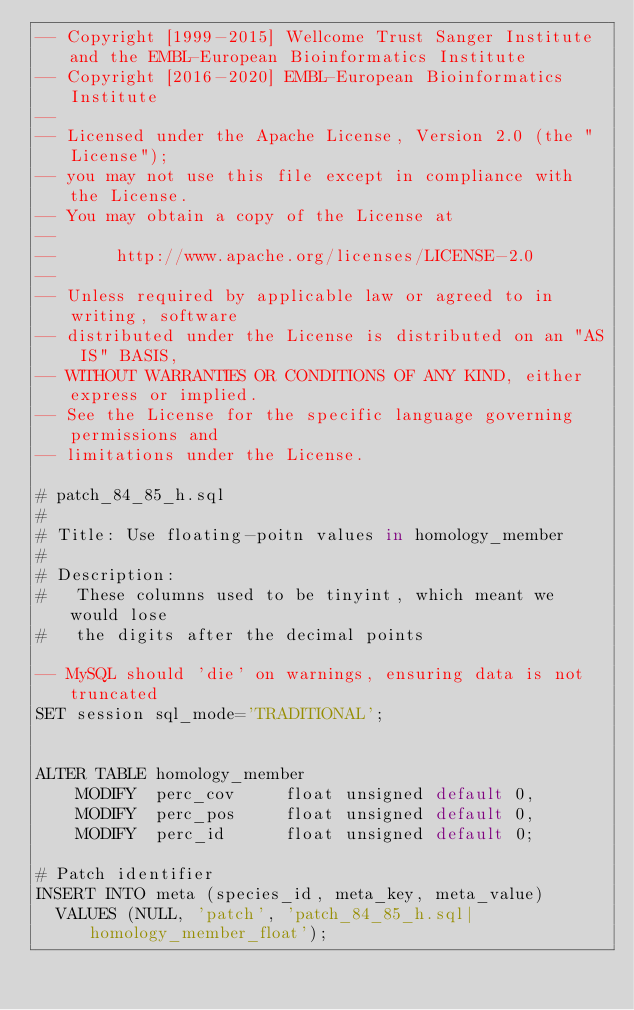Convert code to text. <code><loc_0><loc_0><loc_500><loc_500><_SQL_>-- Copyright [1999-2015] Wellcome Trust Sanger Institute and the EMBL-European Bioinformatics Institute
-- Copyright [2016-2020] EMBL-European Bioinformatics Institute
-- 
-- Licensed under the Apache License, Version 2.0 (the "License");
-- you may not use this file except in compliance with the License.
-- You may obtain a copy of the License at
-- 
--      http://www.apache.org/licenses/LICENSE-2.0
-- 
-- Unless required by applicable law or agreed to in writing, software
-- distributed under the License is distributed on an "AS IS" BASIS,
-- WITHOUT WARRANTIES OR CONDITIONS OF ANY KIND, either express or implied.
-- See the License for the specific language governing permissions and
-- limitations under the License.

# patch_84_85_h.sql
#
# Title: Use floating-poitn values in homology_member
#
# Description:
#   These columns used to be tinyint, which meant we would lose
#   the digits after the decimal points

-- MySQL should 'die' on warnings, ensuring data is not truncated
SET session sql_mode='TRADITIONAL';


ALTER TABLE homology_member
	MODIFY  perc_cov     float unsigned default 0,
	MODIFY  perc_pos     float unsigned default 0,
	MODIFY  perc_id      float unsigned default 0;

# Patch identifier
INSERT INTO meta (species_id, meta_key, meta_value)
  VALUES (NULL, 'patch', 'patch_84_85_h.sql|homology_member_float');
</code> 